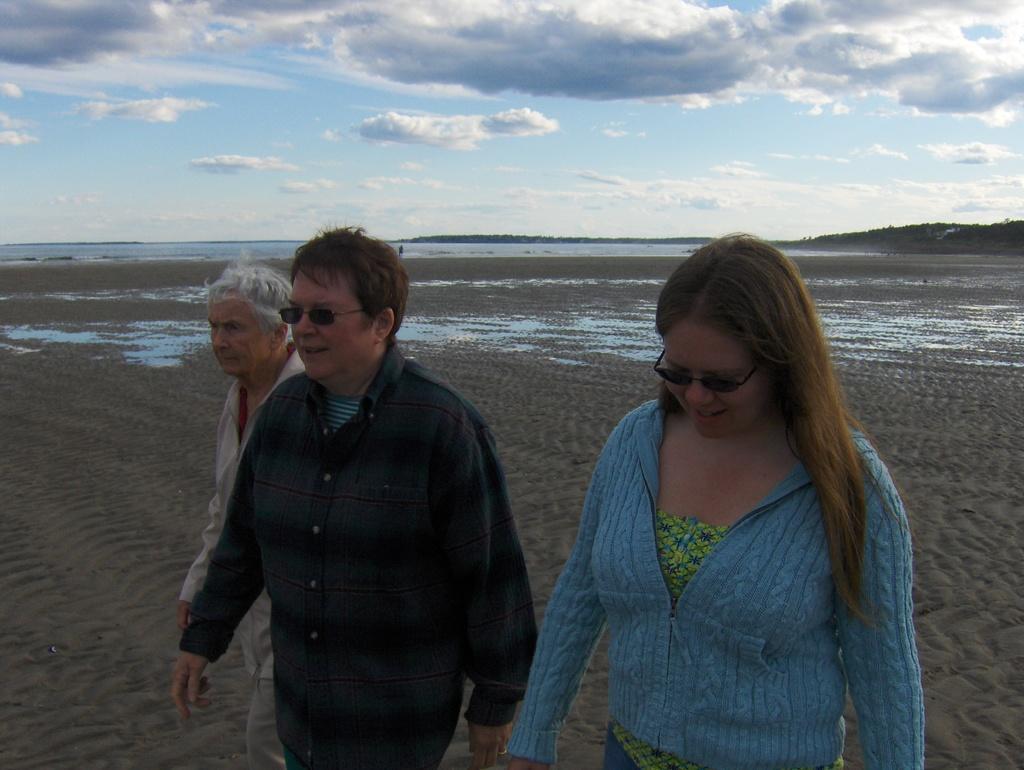Could you give a brief overview of what you see in this image? In this image three people are walking on the sand. At the back side there is river. At the background there is sky. 